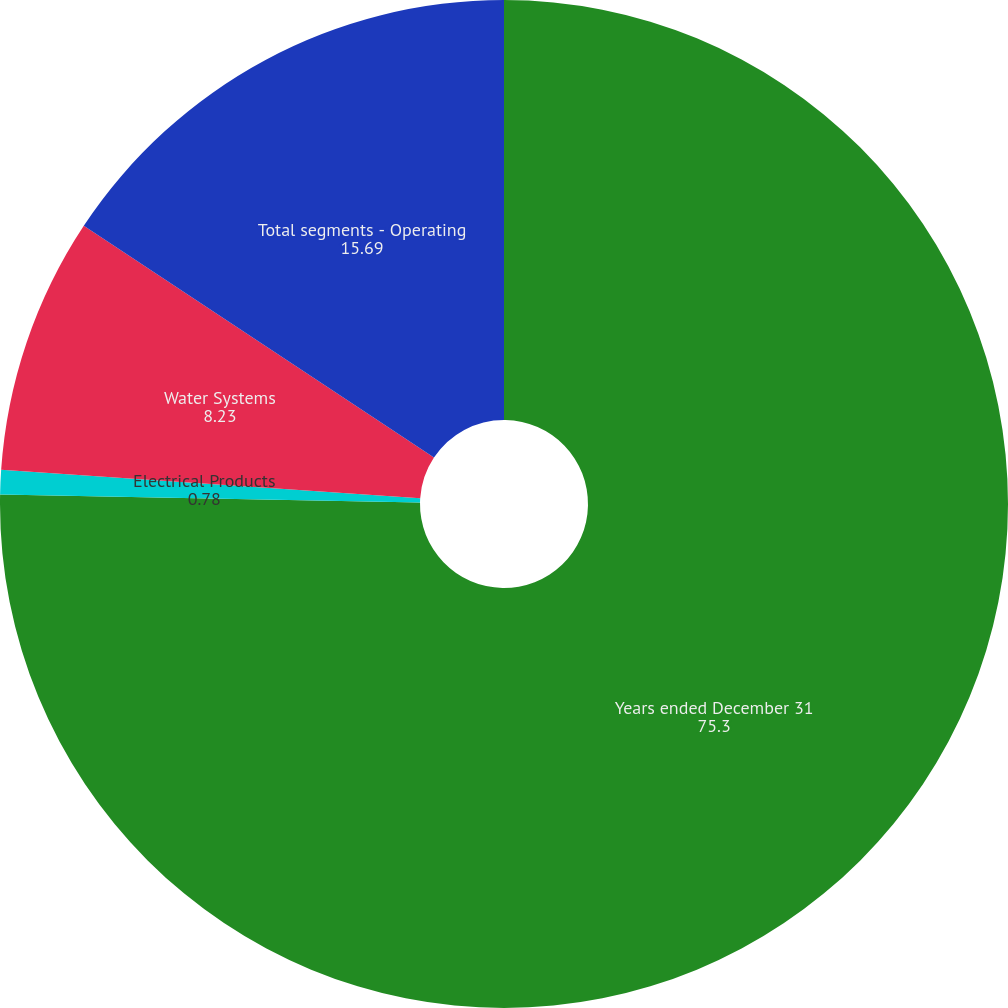Convert chart to OTSL. <chart><loc_0><loc_0><loc_500><loc_500><pie_chart><fcel>Years ended December 31<fcel>Electrical Products<fcel>Water Systems<fcel>Total segments - Operating<nl><fcel>75.3%<fcel>0.78%<fcel>8.23%<fcel>15.69%<nl></chart> 